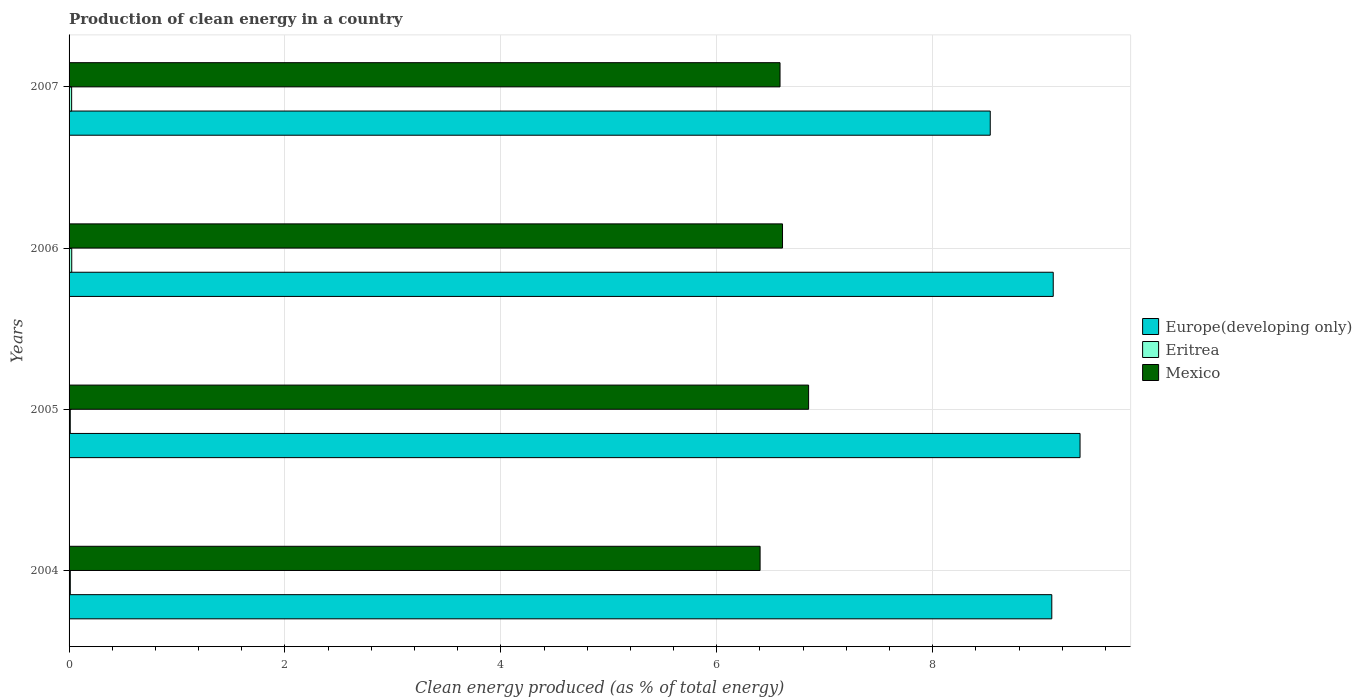How many different coloured bars are there?
Provide a succinct answer. 3. How many groups of bars are there?
Offer a terse response. 4. Are the number of bars per tick equal to the number of legend labels?
Keep it short and to the point. Yes. Are the number of bars on each tick of the Y-axis equal?
Your answer should be very brief. Yes. What is the label of the 3rd group of bars from the top?
Provide a succinct answer. 2005. What is the percentage of clean energy produced in Eritrea in 2005?
Offer a terse response. 0.01. Across all years, what is the maximum percentage of clean energy produced in Europe(developing only)?
Give a very brief answer. 9.36. Across all years, what is the minimum percentage of clean energy produced in Mexico?
Your answer should be very brief. 6.4. What is the total percentage of clean energy produced in Europe(developing only) in the graph?
Your response must be concise. 36.12. What is the difference between the percentage of clean energy produced in Mexico in 2005 and that in 2006?
Offer a terse response. 0.24. What is the difference between the percentage of clean energy produced in Mexico in 2006 and the percentage of clean energy produced in Europe(developing only) in 2005?
Give a very brief answer. -2.76. What is the average percentage of clean energy produced in Europe(developing only) per year?
Provide a succinct answer. 9.03. In the year 2007, what is the difference between the percentage of clean energy produced in Eritrea and percentage of clean energy produced in Mexico?
Offer a terse response. -6.56. In how many years, is the percentage of clean energy produced in Mexico greater than 8.8 %?
Make the answer very short. 0. What is the ratio of the percentage of clean energy produced in Mexico in 2006 to that in 2007?
Ensure brevity in your answer.  1. Is the percentage of clean energy produced in Europe(developing only) in 2004 less than that in 2007?
Give a very brief answer. No. Is the difference between the percentage of clean energy produced in Eritrea in 2005 and 2007 greater than the difference between the percentage of clean energy produced in Mexico in 2005 and 2007?
Give a very brief answer. No. What is the difference between the highest and the second highest percentage of clean energy produced in Europe(developing only)?
Ensure brevity in your answer.  0.25. What is the difference between the highest and the lowest percentage of clean energy produced in Europe(developing only)?
Your answer should be very brief. 0.83. In how many years, is the percentage of clean energy produced in Mexico greater than the average percentage of clean energy produced in Mexico taken over all years?
Your answer should be compact. 1. What does the 1st bar from the top in 2005 represents?
Your response must be concise. Mexico. What does the 2nd bar from the bottom in 2005 represents?
Keep it short and to the point. Eritrea. How many bars are there?
Give a very brief answer. 12. Are all the bars in the graph horizontal?
Your answer should be very brief. Yes. How many years are there in the graph?
Ensure brevity in your answer.  4. How many legend labels are there?
Provide a short and direct response. 3. What is the title of the graph?
Offer a terse response. Production of clean energy in a country. Does "Mali" appear as one of the legend labels in the graph?
Give a very brief answer. No. What is the label or title of the X-axis?
Provide a short and direct response. Clean energy produced (as % of total energy). What is the label or title of the Y-axis?
Offer a very short reply. Years. What is the Clean energy produced (as % of total energy) of Europe(developing only) in 2004?
Provide a short and direct response. 9.1. What is the Clean energy produced (as % of total energy) of Eritrea in 2004?
Your answer should be very brief. 0.01. What is the Clean energy produced (as % of total energy) in Mexico in 2004?
Your answer should be compact. 6.4. What is the Clean energy produced (as % of total energy) in Europe(developing only) in 2005?
Your answer should be compact. 9.36. What is the Clean energy produced (as % of total energy) of Eritrea in 2005?
Offer a very short reply. 0.01. What is the Clean energy produced (as % of total energy) of Mexico in 2005?
Give a very brief answer. 6.85. What is the Clean energy produced (as % of total energy) in Europe(developing only) in 2006?
Keep it short and to the point. 9.12. What is the Clean energy produced (as % of total energy) in Eritrea in 2006?
Offer a very short reply. 0.02. What is the Clean energy produced (as % of total energy) in Mexico in 2006?
Give a very brief answer. 6.61. What is the Clean energy produced (as % of total energy) of Europe(developing only) in 2007?
Ensure brevity in your answer.  8.53. What is the Clean energy produced (as % of total energy) of Eritrea in 2007?
Offer a very short reply. 0.02. What is the Clean energy produced (as % of total energy) of Mexico in 2007?
Offer a terse response. 6.59. Across all years, what is the maximum Clean energy produced (as % of total energy) of Europe(developing only)?
Make the answer very short. 9.36. Across all years, what is the maximum Clean energy produced (as % of total energy) in Eritrea?
Make the answer very short. 0.02. Across all years, what is the maximum Clean energy produced (as % of total energy) of Mexico?
Provide a short and direct response. 6.85. Across all years, what is the minimum Clean energy produced (as % of total energy) in Europe(developing only)?
Give a very brief answer. 8.53. Across all years, what is the minimum Clean energy produced (as % of total energy) in Eritrea?
Make the answer very short. 0.01. Across all years, what is the minimum Clean energy produced (as % of total energy) in Mexico?
Make the answer very short. 6.4. What is the total Clean energy produced (as % of total energy) in Europe(developing only) in the graph?
Make the answer very short. 36.12. What is the total Clean energy produced (as % of total energy) in Eritrea in the graph?
Offer a very short reply. 0.07. What is the total Clean energy produced (as % of total energy) of Mexico in the graph?
Your response must be concise. 26.45. What is the difference between the Clean energy produced (as % of total energy) of Europe(developing only) in 2004 and that in 2005?
Provide a short and direct response. -0.26. What is the difference between the Clean energy produced (as % of total energy) in Mexico in 2004 and that in 2005?
Offer a very short reply. -0.45. What is the difference between the Clean energy produced (as % of total energy) of Europe(developing only) in 2004 and that in 2006?
Provide a succinct answer. -0.01. What is the difference between the Clean energy produced (as % of total energy) of Eritrea in 2004 and that in 2006?
Ensure brevity in your answer.  -0.01. What is the difference between the Clean energy produced (as % of total energy) of Mexico in 2004 and that in 2006?
Your answer should be very brief. -0.21. What is the difference between the Clean energy produced (as % of total energy) of Europe(developing only) in 2004 and that in 2007?
Offer a terse response. 0.57. What is the difference between the Clean energy produced (as % of total energy) of Eritrea in 2004 and that in 2007?
Provide a succinct answer. -0.01. What is the difference between the Clean energy produced (as % of total energy) in Mexico in 2004 and that in 2007?
Keep it short and to the point. -0.18. What is the difference between the Clean energy produced (as % of total energy) in Europe(developing only) in 2005 and that in 2006?
Make the answer very short. 0.25. What is the difference between the Clean energy produced (as % of total energy) in Eritrea in 2005 and that in 2006?
Ensure brevity in your answer.  -0.01. What is the difference between the Clean energy produced (as % of total energy) in Mexico in 2005 and that in 2006?
Provide a short and direct response. 0.24. What is the difference between the Clean energy produced (as % of total energy) of Europe(developing only) in 2005 and that in 2007?
Make the answer very short. 0.83. What is the difference between the Clean energy produced (as % of total energy) of Eritrea in 2005 and that in 2007?
Offer a very short reply. -0.01. What is the difference between the Clean energy produced (as % of total energy) in Mexico in 2005 and that in 2007?
Give a very brief answer. 0.26. What is the difference between the Clean energy produced (as % of total energy) in Europe(developing only) in 2006 and that in 2007?
Give a very brief answer. 0.58. What is the difference between the Clean energy produced (as % of total energy) of Eritrea in 2006 and that in 2007?
Keep it short and to the point. 0. What is the difference between the Clean energy produced (as % of total energy) in Mexico in 2006 and that in 2007?
Ensure brevity in your answer.  0.02. What is the difference between the Clean energy produced (as % of total energy) in Europe(developing only) in 2004 and the Clean energy produced (as % of total energy) in Eritrea in 2005?
Offer a very short reply. 9.09. What is the difference between the Clean energy produced (as % of total energy) of Europe(developing only) in 2004 and the Clean energy produced (as % of total energy) of Mexico in 2005?
Your response must be concise. 2.25. What is the difference between the Clean energy produced (as % of total energy) in Eritrea in 2004 and the Clean energy produced (as % of total energy) in Mexico in 2005?
Provide a succinct answer. -6.84. What is the difference between the Clean energy produced (as % of total energy) of Europe(developing only) in 2004 and the Clean energy produced (as % of total energy) of Eritrea in 2006?
Make the answer very short. 9.08. What is the difference between the Clean energy produced (as % of total energy) of Europe(developing only) in 2004 and the Clean energy produced (as % of total energy) of Mexico in 2006?
Offer a very short reply. 2.49. What is the difference between the Clean energy produced (as % of total energy) of Eritrea in 2004 and the Clean energy produced (as % of total energy) of Mexico in 2006?
Offer a very short reply. -6.6. What is the difference between the Clean energy produced (as % of total energy) in Europe(developing only) in 2004 and the Clean energy produced (as % of total energy) in Eritrea in 2007?
Your response must be concise. 9.08. What is the difference between the Clean energy produced (as % of total energy) of Europe(developing only) in 2004 and the Clean energy produced (as % of total energy) of Mexico in 2007?
Make the answer very short. 2.52. What is the difference between the Clean energy produced (as % of total energy) of Eritrea in 2004 and the Clean energy produced (as % of total energy) of Mexico in 2007?
Your answer should be compact. -6.57. What is the difference between the Clean energy produced (as % of total energy) of Europe(developing only) in 2005 and the Clean energy produced (as % of total energy) of Eritrea in 2006?
Provide a short and direct response. 9.34. What is the difference between the Clean energy produced (as % of total energy) of Europe(developing only) in 2005 and the Clean energy produced (as % of total energy) of Mexico in 2006?
Your answer should be compact. 2.76. What is the difference between the Clean energy produced (as % of total energy) in Eritrea in 2005 and the Clean energy produced (as % of total energy) in Mexico in 2006?
Your answer should be compact. -6.6. What is the difference between the Clean energy produced (as % of total energy) of Europe(developing only) in 2005 and the Clean energy produced (as % of total energy) of Eritrea in 2007?
Your answer should be very brief. 9.34. What is the difference between the Clean energy produced (as % of total energy) in Europe(developing only) in 2005 and the Clean energy produced (as % of total energy) in Mexico in 2007?
Provide a short and direct response. 2.78. What is the difference between the Clean energy produced (as % of total energy) in Eritrea in 2005 and the Clean energy produced (as % of total energy) in Mexico in 2007?
Keep it short and to the point. -6.57. What is the difference between the Clean energy produced (as % of total energy) in Europe(developing only) in 2006 and the Clean energy produced (as % of total energy) in Eritrea in 2007?
Provide a succinct answer. 9.09. What is the difference between the Clean energy produced (as % of total energy) in Europe(developing only) in 2006 and the Clean energy produced (as % of total energy) in Mexico in 2007?
Your response must be concise. 2.53. What is the difference between the Clean energy produced (as % of total energy) of Eritrea in 2006 and the Clean energy produced (as % of total energy) of Mexico in 2007?
Your answer should be compact. -6.56. What is the average Clean energy produced (as % of total energy) of Europe(developing only) per year?
Your answer should be very brief. 9.03. What is the average Clean energy produced (as % of total energy) in Eritrea per year?
Your answer should be very brief. 0.02. What is the average Clean energy produced (as % of total energy) of Mexico per year?
Provide a short and direct response. 6.61. In the year 2004, what is the difference between the Clean energy produced (as % of total energy) of Europe(developing only) and Clean energy produced (as % of total energy) of Eritrea?
Keep it short and to the point. 9.09. In the year 2004, what is the difference between the Clean energy produced (as % of total energy) in Europe(developing only) and Clean energy produced (as % of total energy) in Mexico?
Keep it short and to the point. 2.7. In the year 2004, what is the difference between the Clean energy produced (as % of total energy) in Eritrea and Clean energy produced (as % of total energy) in Mexico?
Keep it short and to the point. -6.39. In the year 2005, what is the difference between the Clean energy produced (as % of total energy) of Europe(developing only) and Clean energy produced (as % of total energy) of Eritrea?
Your response must be concise. 9.35. In the year 2005, what is the difference between the Clean energy produced (as % of total energy) of Europe(developing only) and Clean energy produced (as % of total energy) of Mexico?
Keep it short and to the point. 2.51. In the year 2005, what is the difference between the Clean energy produced (as % of total energy) in Eritrea and Clean energy produced (as % of total energy) in Mexico?
Your answer should be very brief. -6.84. In the year 2006, what is the difference between the Clean energy produced (as % of total energy) in Europe(developing only) and Clean energy produced (as % of total energy) in Eritrea?
Offer a very short reply. 9.09. In the year 2006, what is the difference between the Clean energy produced (as % of total energy) of Europe(developing only) and Clean energy produced (as % of total energy) of Mexico?
Give a very brief answer. 2.51. In the year 2006, what is the difference between the Clean energy produced (as % of total energy) in Eritrea and Clean energy produced (as % of total energy) in Mexico?
Make the answer very short. -6.58. In the year 2007, what is the difference between the Clean energy produced (as % of total energy) in Europe(developing only) and Clean energy produced (as % of total energy) in Eritrea?
Make the answer very short. 8.51. In the year 2007, what is the difference between the Clean energy produced (as % of total energy) in Europe(developing only) and Clean energy produced (as % of total energy) in Mexico?
Give a very brief answer. 1.95. In the year 2007, what is the difference between the Clean energy produced (as % of total energy) in Eritrea and Clean energy produced (as % of total energy) in Mexico?
Provide a succinct answer. -6.56. What is the ratio of the Clean energy produced (as % of total energy) in Mexico in 2004 to that in 2005?
Offer a terse response. 0.93. What is the ratio of the Clean energy produced (as % of total energy) in Europe(developing only) in 2004 to that in 2006?
Your answer should be very brief. 1. What is the ratio of the Clean energy produced (as % of total energy) in Eritrea in 2004 to that in 2006?
Give a very brief answer. 0.47. What is the ratio of the Clean energy produced (as % of total energy) of Mexico in 2004 to that in 2006?
Your response must be concise. 0.97. What is the ratio of the Clean energy produced (as % of total energy) of Europe(developing only) in 2004 to that in 2007?
Your response must be concise. 1.07. What is the ratio of the Clean energy produced (as % of total energy) of Eritrea in 2004 to that in 2007?
Provide a succinct answer. 0.48. What is the ratio of the Clean energy produced (as % of total energy) of Europe(developing only) in 2005 to that in 2006?
Provide a short and direct response. 1.03. What is the ratio of the Clean energy produced (as % of total energy) in Eritrea in 2005 to that in 2006?
Keep it short and to the point. 0.46. What is the ratio of the Clean energy produced (as % of total energy) of Mexico in 2005 to that in 2006?
Give a very brief answer. 1.04. What is the ratio of the Clean energy produced (as % of total energy) in Europe(developing only) in 2005 to that in 2007?
Provide a short and direct response. 1.1. What is the ratio of the Clean energy produced (as % of total energy) in Eritrea in 2005 to that in 2007?
Your response must be concise. 0.47. What is the ratio of the Clean energy produced (as % of total energy) of Mexico in 2005 to that in 2007?
Offer a very short reply. 1.04. What is the ratio of the Clean energy produced (as % of total energy) in Europe(developing only) in 2006 to that in 2007?
Your answer should be compact. 1.07. What is the ratio of the Clean energy produced (as % of total energy) in Eritrea in 2006 to that in 2007?
Your response must be concise. 1.03. What is the ratio of the Clean energy produced (as % of total energy) in Mexico in 2006 to that in 2007?
Provide a short and direct response. 1. What is the difference between the highest and the second highest Clean energy produced (as % of total energy) in Europe(developing only)?
Your answer should be very brief. 0.25. What is the difference between the highest and the second highest Clean energy produced (as % of total energy) in Eritrea?
Provide a succinct answer. 0. What is the difference between the highest and the second highest Clean energy produced (as % of total energy) in Mexico?
Your answer should be very brief. 0.24. What is the difference between the highest and the lowest Clean energy produced (as % of total energy) of Europe(developing only)?
Provide a succinct answer. 0.83. What is the difference between the highest and the lowest Clean energy produced (as % of total energy) of Eritrea?
Offer a very short reply. 0.01. What is the difference between the highest and the lowest Clean energy produced (as % of total energy) of Mexico?
Provide a short and direct response. 0.45. 